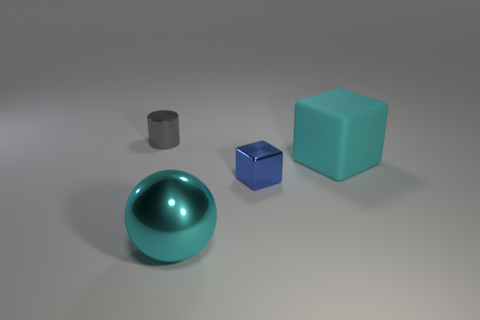Subtract all blue blocks. How many blocks are left? 1 Add 1 metal spheres. How many objects exist? 5 Subtract 1 cyan cubes. How many objects are left? 3 Subtract all balls. How many objects are left? 3 Subtract 2 blocks. How many blocks are left? 0 Subtract all yellow cubes. Subtract all brown cylinders. How many cubes are left? 2 Subtract all yellow cylinders. How many cyan cubes are left? 1 Subtract all red matte cylinders. Subtract all cyan matte blocks. How many objects are left? 3 Add 4 big cyan things. How many big cyan things are left? 6 Add 4 cyan metallic balls. How many cyan metallic balls exist? 5 